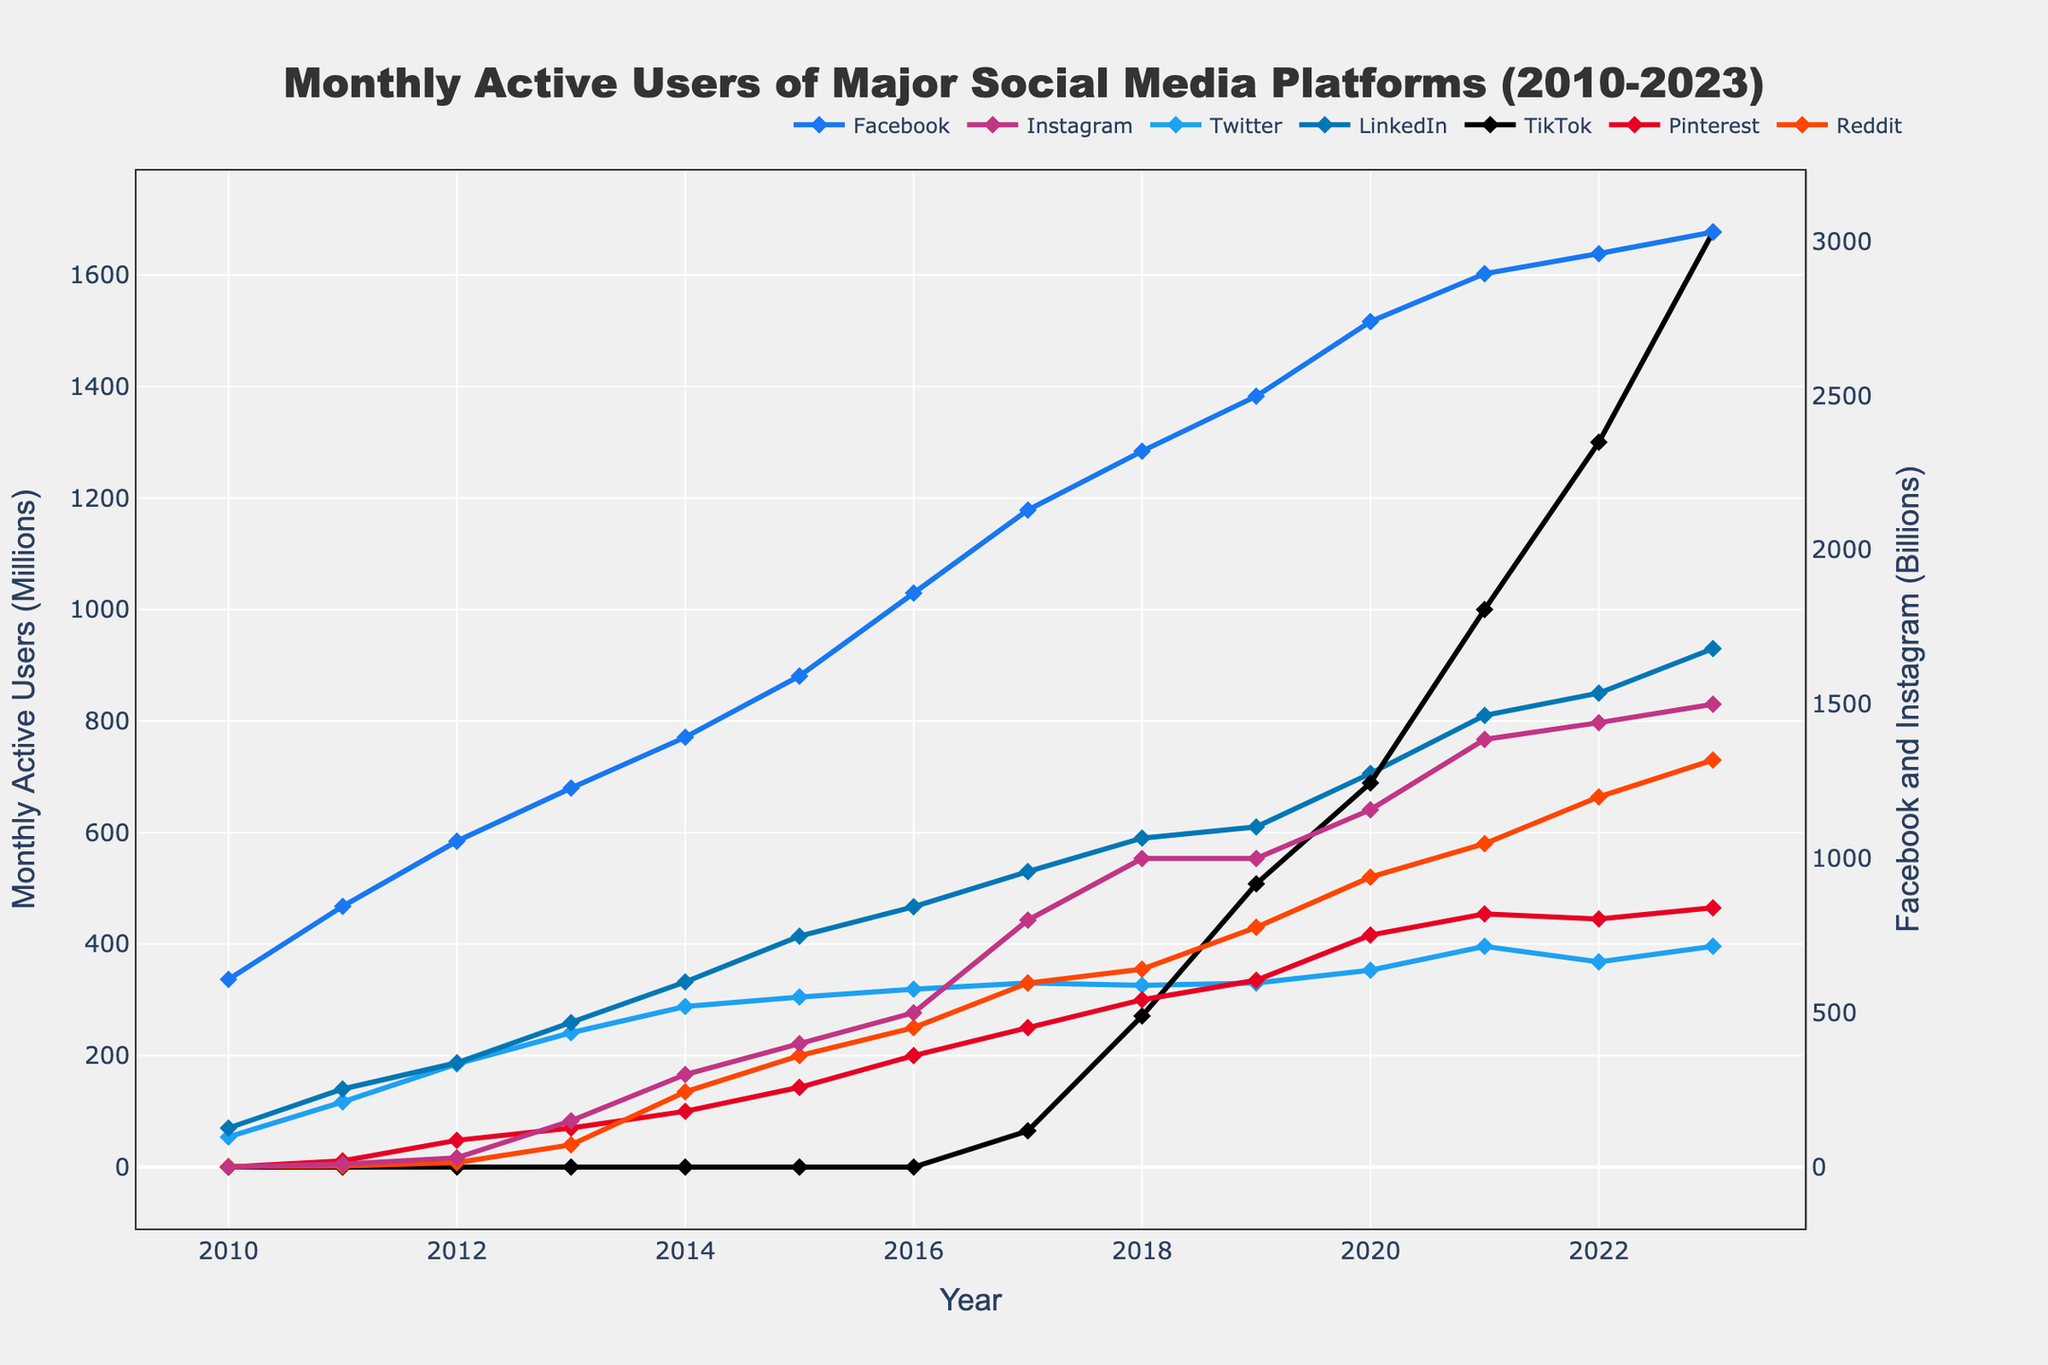How many monthly active users did LinkedIn have in 2020? Locate the intersection of the LinkedIn line (LinkedIn color) and the 2020 vertical line.
Answer: 706 million Which platform had the fastest increase in monthly active users from 2010 to 2023? Compare the slopes of the lines for each platform from 2010 to 2023. TikTok shows the steepest slope.
Answer: TikTok What is the difference in monthly active users between Facebook and Instagram in 2023? For 2023, find the data points for Facebook and Instagram, subtract Instagram's users from Facebook's users: 3030 million - 1500 million.
Answer: 1530 million How has the number of Pinterest users changed from 2010 to 2023? Trace the line for Pinterest from 2010 to 2023. Observe the starting point (0 in 2010) and ending point (465 in 2023).
Answer: Grew from 0 to 465 million Which platform had a decline in monthly active users between any two consecutive years? Look at the trend lines for each platform over the years for any downward slopes. Twitter shows a slight decrease from 2021 to 2022.
Answer: Twitter What was the total number of monthly active users for TikTok and Reddit combined in 2021? Locate the data points for TikTok and Reddit in 2021 and sum them: 1000 million (TikTok) + 580 million (Reddit).
Answer: 1580 million How does the growth of TikTok compare to Instagram from 2017 to 2023? Observe the change in data points for both TikTok and Instagram between 2017 and 2023. TikTok grows from 65 million to 1677 million, and Instagram from 800 million to 1500 million.
Answer: TikTok grew faster What is the median number of monthly active users for Twitter from 2010 to 2023? List Twitter's values from 2010 to 2023: 54, 117, 185, 241, 288, 305, 319, 330, 326, 330, 353, 396, 368, 396. The median is the middle value: (319 + 326)/2 = 322.5.
Answer: 322.5 million By how many millions did Facebook's monthly active users increase from 2012 to 2018? Find the data points for Facebook in 2012 and 2018, then subtract: 2320 million - 1056 million.
Answer: 1264 million 